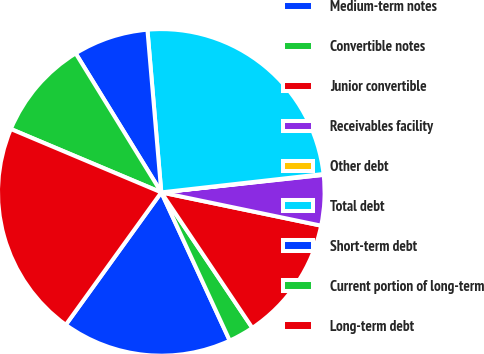Convert chart to OTSL. <chart><loc_0><loc_0><loc_500><loc_500><pie_chart><fcel>Medium-term notes<fcel>Convertible notes<fcel>Junior convertible<fcel>Receivables facility<fcel>Other debt<fcel>Total debt<fcel>Short-term debt<fcel>Current portion of long-term<fcel>Long-term debt<nl><fcel>16.83%<fcel>2.53%<fcel>12.32%<fcel>4.98%<fcel>0.08%<fcel>24.56%<fcel>7.43%<fcel>9.87%<fcel>21.4%<nl></chart> 